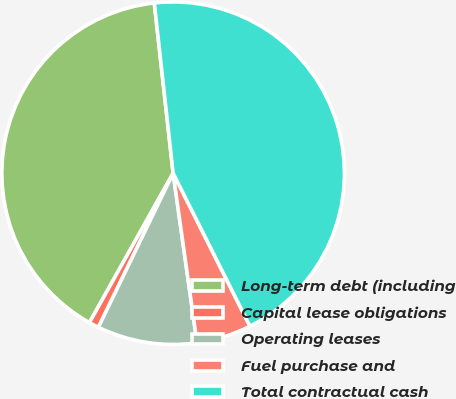Convert chart. <chart><loc_0><loc_0><loc_500><loc_500><pie_chart><fcel>Long-term debt (including<fcel>Capital lease obligations<fcel>Operating leases<fcel>Fuel purchase and<fcel>Total contractual cash<nl><fcel>40.12%<fcel>0.94%<fcel>9.41%<fcel>5.18%<fcel>44.35%<nl></chart> 